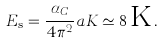<formula> <loc_0><loc_0><loc_500><loc_500>E _ { \text  s}=\frac{\alpha_{C} } { 4 \pi ^ { 2 } } a K \simeq 8 \, { \text  K}\, .</formula> 